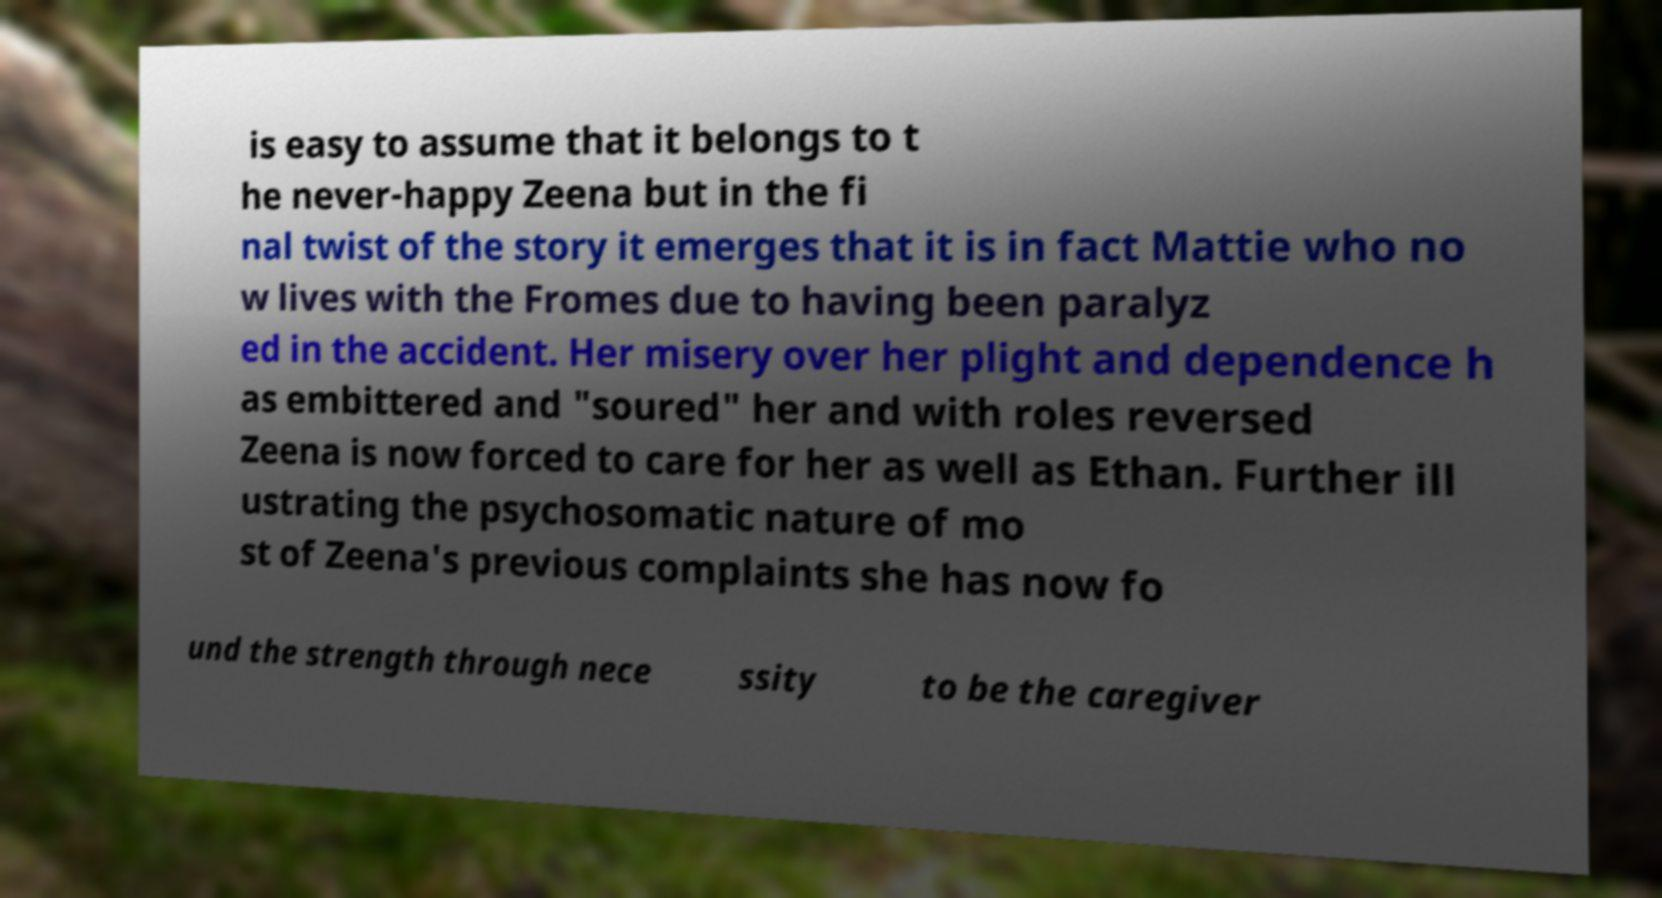Can you accurately transcribe the text from the provided image for me? is easy to assume that it belongs to t he never-happy Zeena but in the fi nal twist of the story it emerges that it is in fact Mattie who no w lives with the Fromes due to having been paralyz ed in the accident. Her misery over her plight and dependence h as embittered and "soured" her and with roles reversed Zeena is now forced to care for her as well as Ethan. Further ill ustrating the psychosomatic nature of mo st of Zeena's previous complaints she has now fo und the strength through nece ssity to be the caregiver 